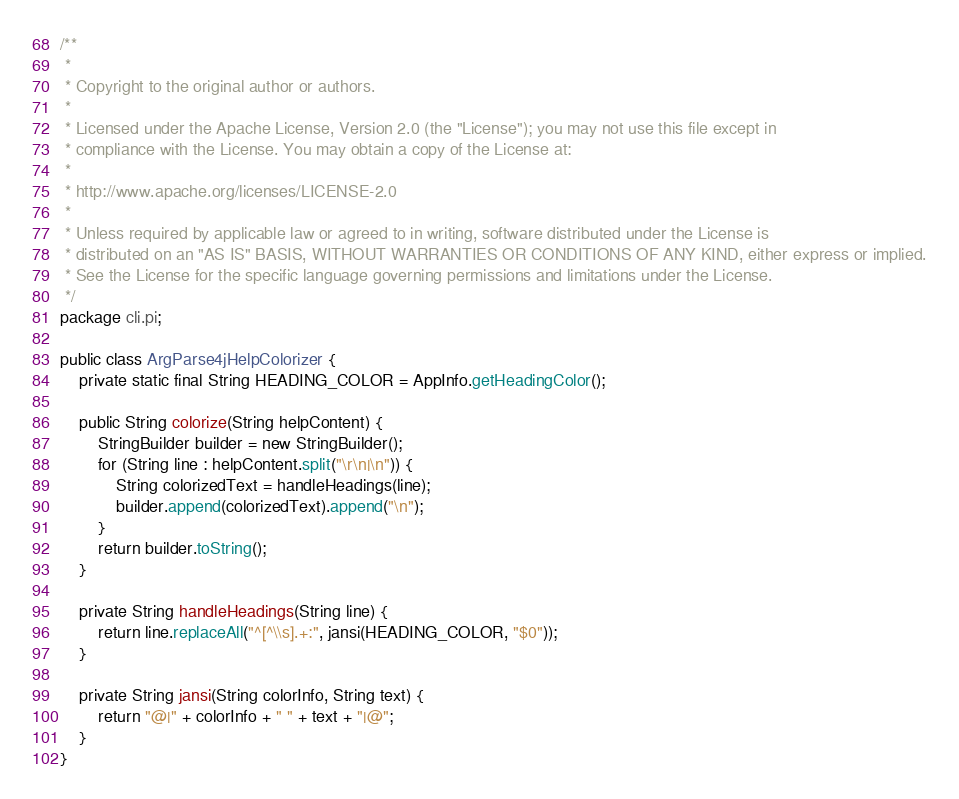<code> <loc_0><loc_0><loc_500><loc_500><_Java_>/**
 *
 * Copyright to the original author or authors.
 *
 * Licensed under the Apache License, Version 2.0 (the "License"); you may not use this file except in
 * compliance with the License. You may obtain a copy of the License at:
 *
 * http://www.apache.org/licenses/LICENSE-2.0
 *
 * Unless required by applicable law or agreed to in writing, software distributed under the License is
 * distributed on an "AS IS" BASIS, WITHOUT WARRANTIES OR CONDITIONS OF ANY KIND, either express or implied.
 * See the License for the specific language governing permissions and limitations under the License.
 */
package cli.pi;

public class ArgParse4jHelpColorizer {
    private static final String HEADING_COLOR = AppInfo.getHeadingColor();

    public String colorize(String helpContent) {
        StringBuilder builder = new StringBuilder();
        for (String line : helpContent.split("\r\n|\n")) {
            String colorizedText = handleHeadings(line);
            builder.append(colorizedText).append("\n");
        }
        return builder.toString();
    }

    private String handleHeadings(String line) {
        return line.replaceAll("^[^\\s].+:", jansi(HEADING_COLOR, "$0"));
    }

    private String jansi(String colorInfo, String text) {
        return "@|" + colorInfo + " " + text + "|@";
    }
}
</code> 